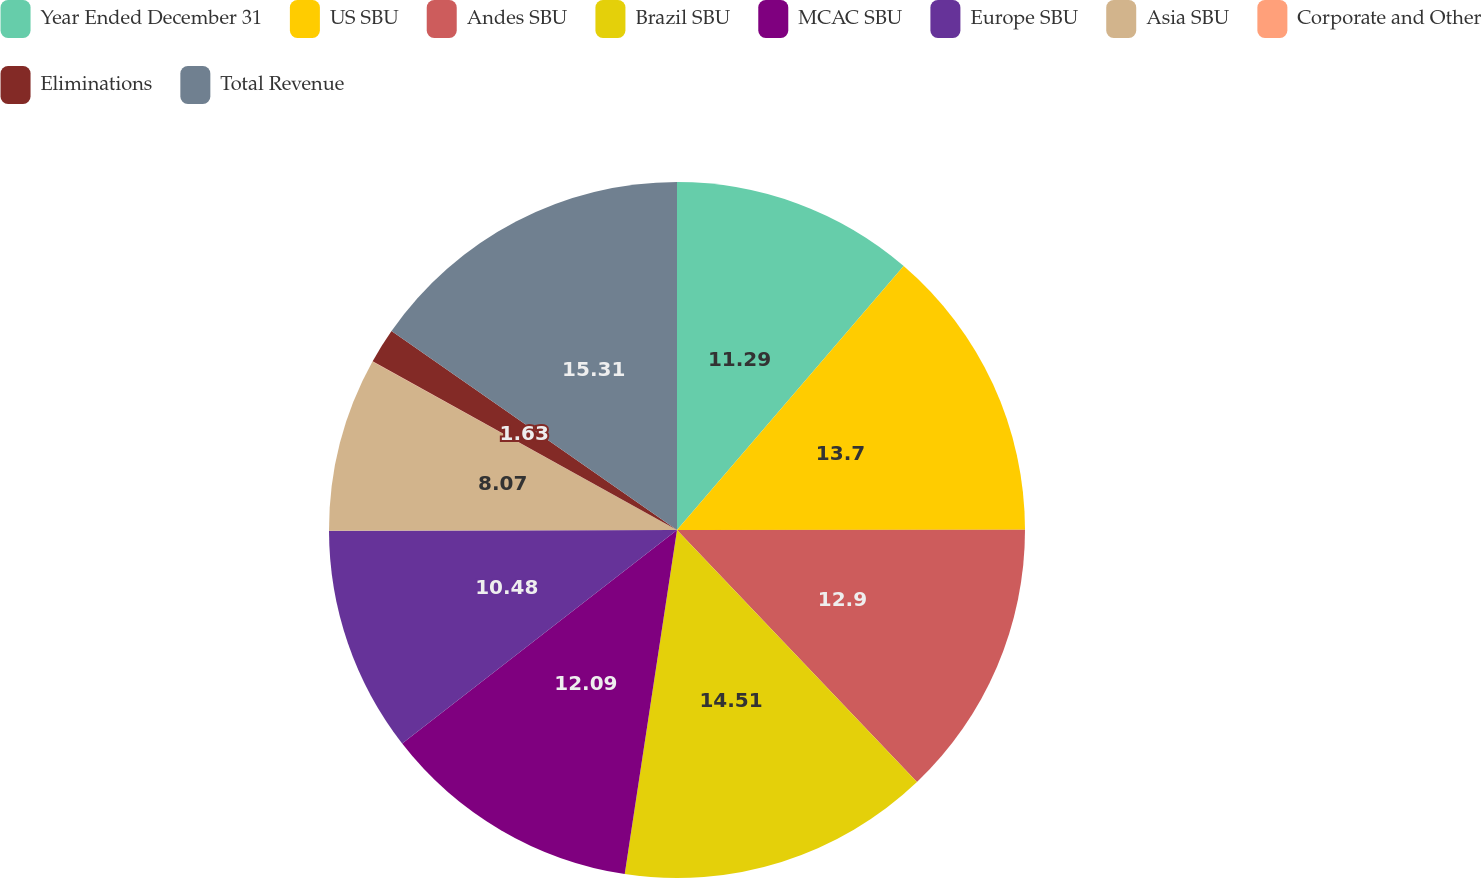Convert chart. <chart><loc_0><loc_0><loc_500><loc_500><pie_chart><fcel>Year Ended December 31<fcel>US SBU<fcel>Andes SBU<fcel>Brazil SBU<fcel>MCAC SBU<fcel>Europe SBU<fcel>Asia SBU<fcel>Corporate and Other<fcel>Eliminations<fcel>Total Revenue<nl><fcel>11.29%<fcel>13.7%<fcel>12.9%<fcel>14.51%<fcel>12.09%<fcel>10.48%<fcel>8.07%<fcel>0.02%<fcel>1.63%<fcel>15.31%<nl></chart> 